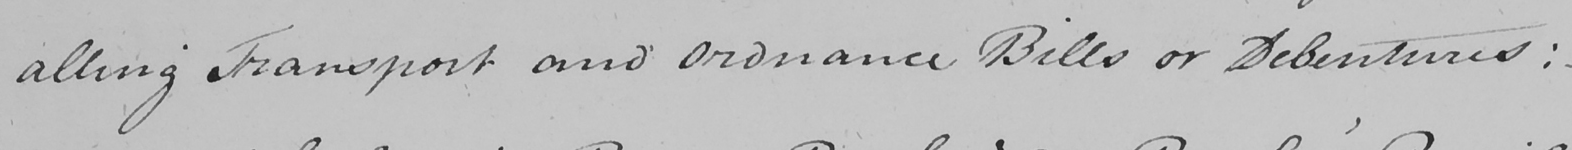Please transcribe the handwritten text in this image. alling Transport and Ordnance Bills or Debentures :   _ 